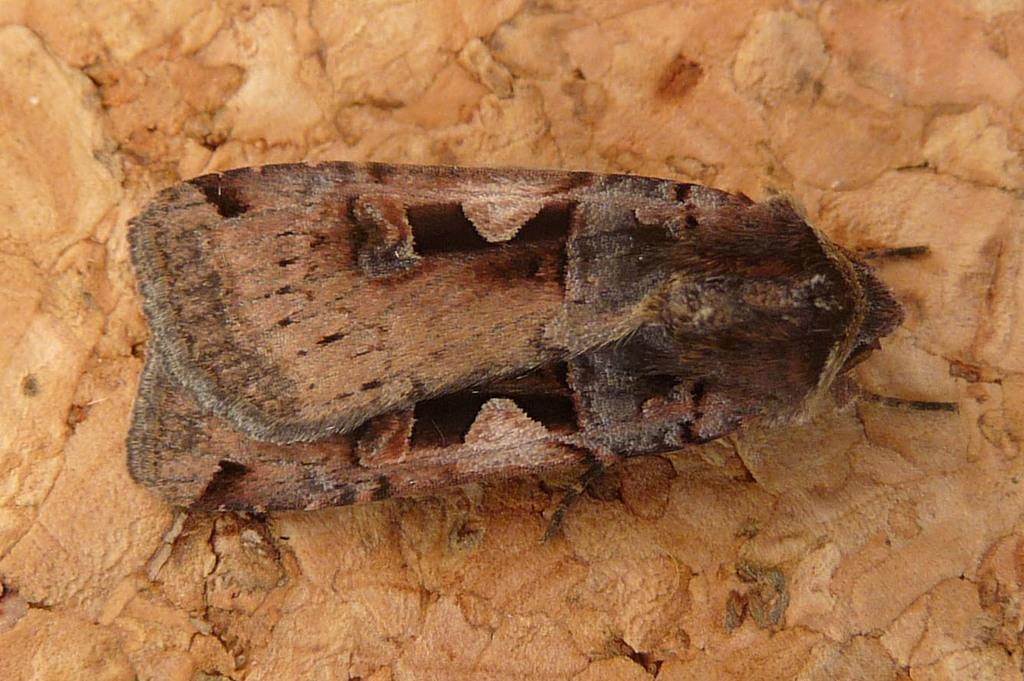What type of creature can be seen in the image? There is an insect in the image. Where is the insect located in the image? The insect is on a surface. What type of bone can be seen in the image? There is no bone present in the image; it features an insect on a surface. What day of the week is depicted in the image? The image does not depict a specific day of the week; it only shows an insect on a surface. 